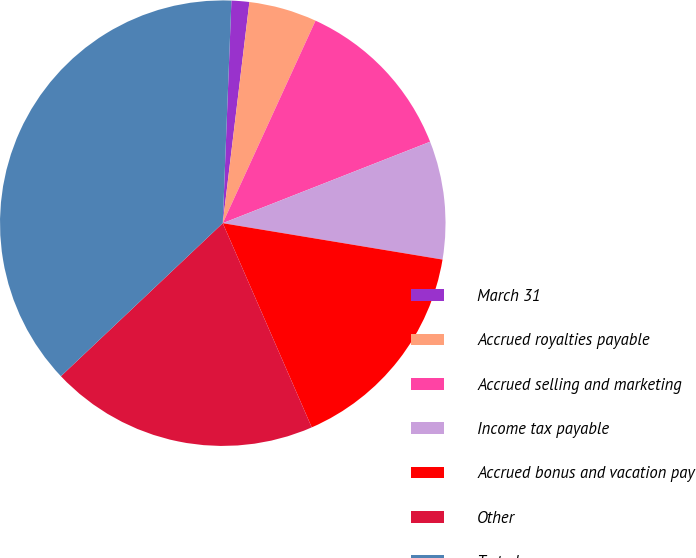Convert chart. <chart><loc_0><loc_0><loc_500><loc_500><pie_chart><fcel>March 31<fcel>Accrued royalties payable<fcel>Accrued selling and marketing<fcel>Income tax payable<fcel>Accrued bonus and vacation pay<fcel>Other<fcel>To ta l<nl><fcel>1.29%<fcel>4.93%<fcel>12.21%<fcel>8.57%<fcel>15.85%<fcel>19.49%<fcel>37.68%<nl></chart> 